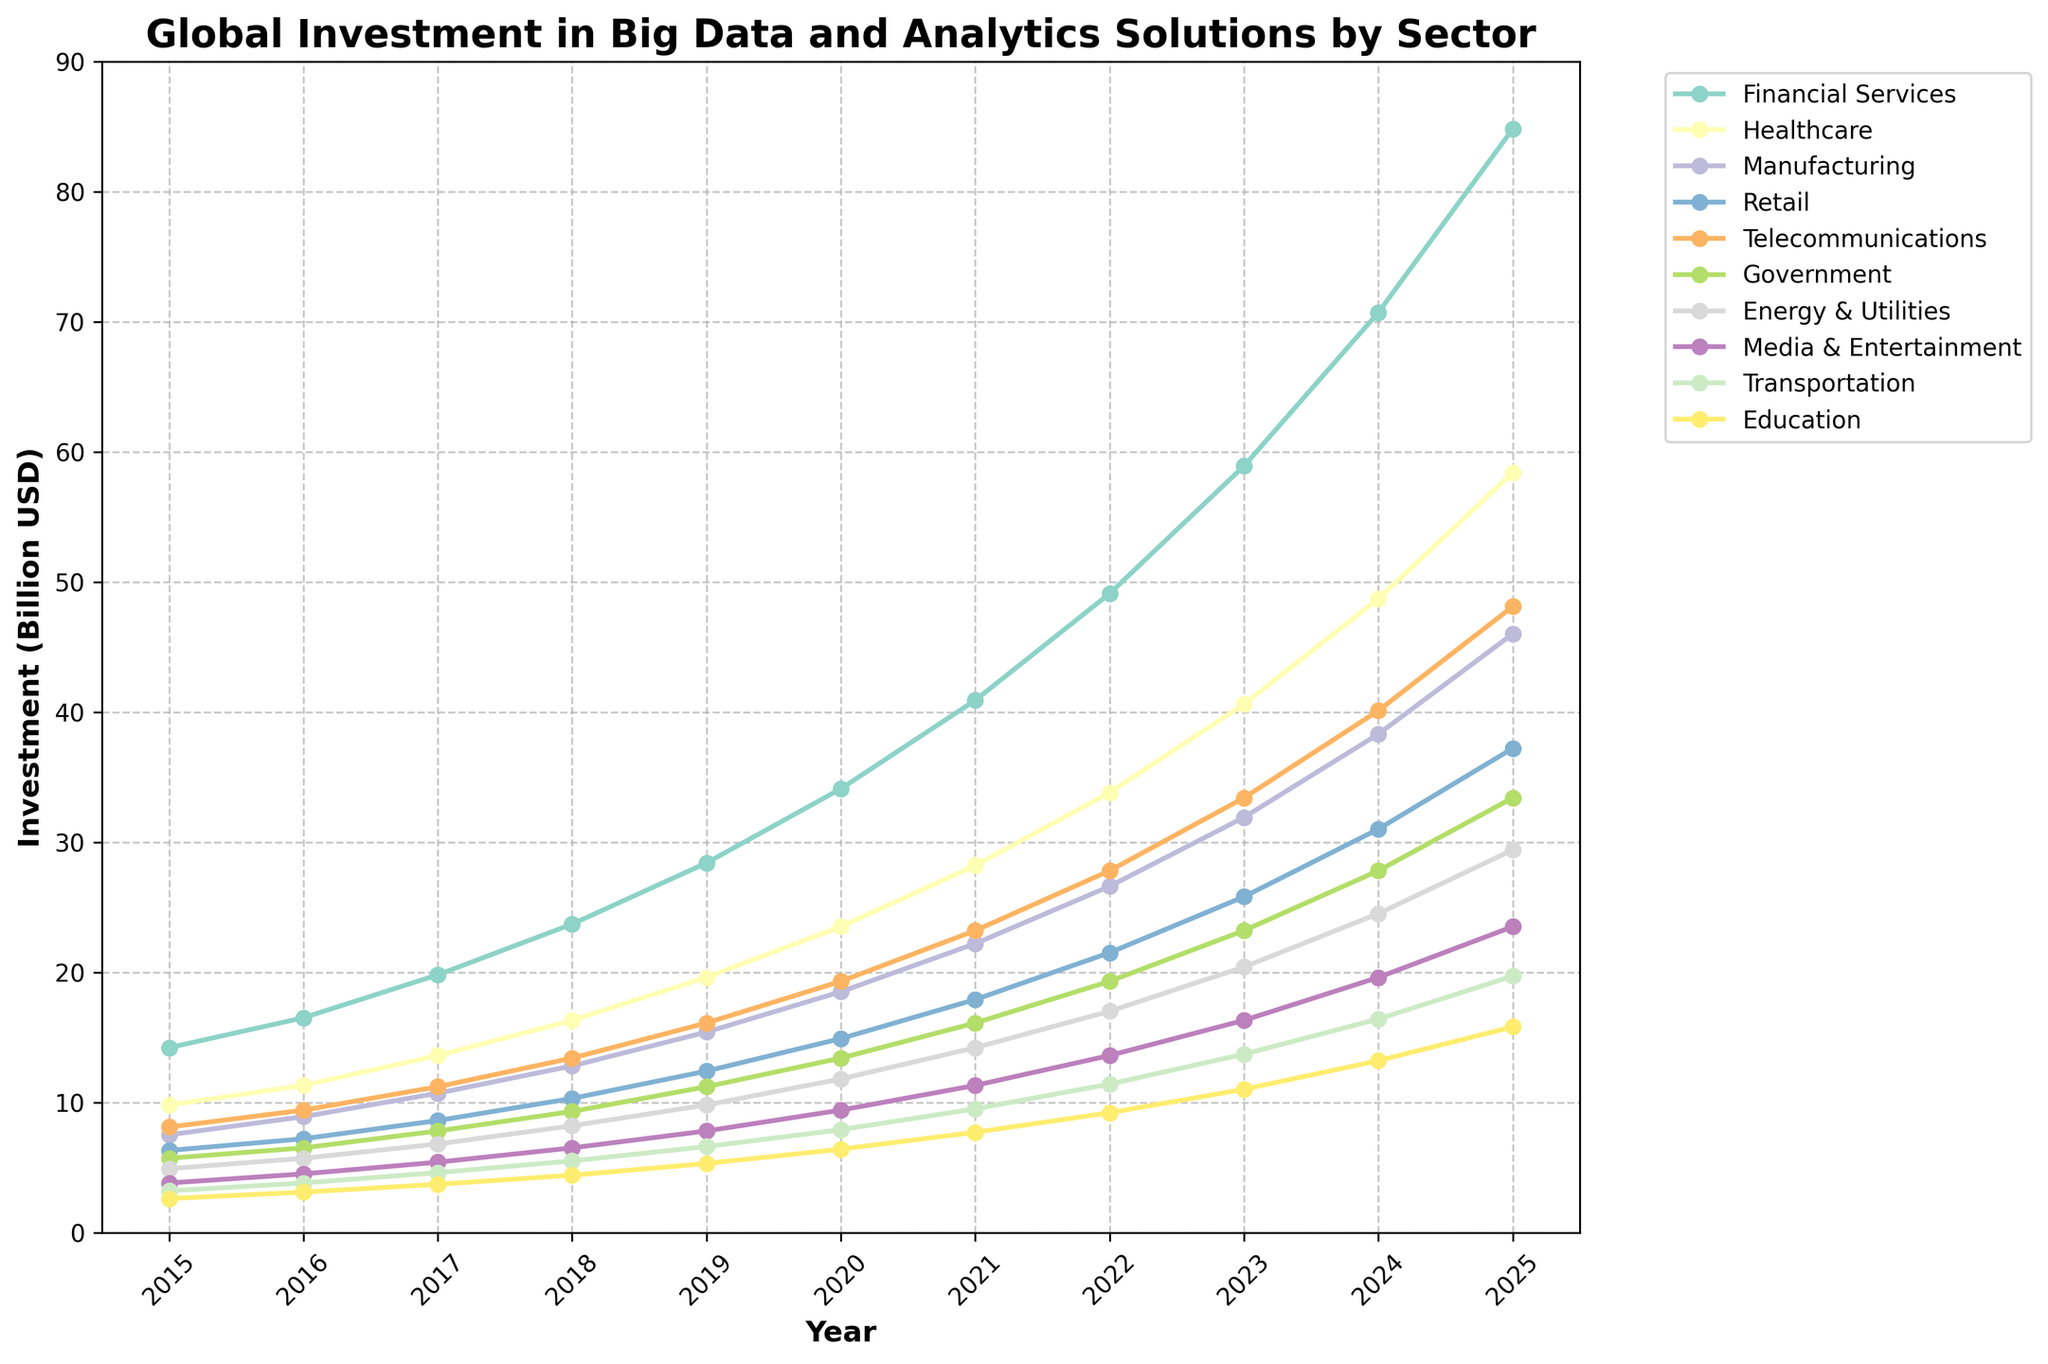How did the investments in the healthcare sector change from 2015 to 2025? To determine this, we look at the line representing the healthcare sector. In 2015, the investment was 9.8 billion USD, and in 2025, it rose to 58.4 billion USD. Therefore, there was an increase of 48.6 billion USD over these years.
Answer: Increased by 48.6 billion USD Which sector had the highest investment in 2025? By examining the endpoint of the lines for each sector in 2025, it is clear that the financial services sector had the highest investment, reaching 84.8 billion USD.
Answer: Financial Services What is the difference in investment between the manufacturing and retail sectors in 2024? We locate the points for the manufacturing (38.3 billion USD) and retail (31.0 billion USD) sectors in 2024 and subtract the value of retail from manufacturing: 38.3 - 31.0 = 7.3 billion USD.
Answer: 7.3 billion USD Which two sectors had the most significant increase in investment from 2015 to 2020? By comparing the rise for each sector between these two years, the financial services sector increased from 14.2 to 34.1 billion USD (increase of 19.9 billion USD) and the healthcare sector from 9.8 to 23.5 billion USD (increase of 13.7 billion USD). These are the two largest increases.
Answer: Financial Services and Healthcare In which year did the telecommunications sector surpass 25 billion USD in investment? Examining the telecommunications line, it is observed that it reaches 25.8 billion USD in 2023, surpassing the 25 billion USD threshold.
Answer: 2023 What was the total investment in big data and analytics solutions for all sectors combined in 2017? Adding up the investments for all sectors in 2017: 19.8 + 13.6 + 10.7 + 8.6 + 11.2 + 7.8 + 6.8 + 5.4 + 4.6 + 3.7 = 92.2 billion USD.
Answer: 92.2 billion USD Which sector consistently showed an increase in investment every year from 2015 to 2025? By inspecting the trend lines for all sectors, we see that all sectors show a consistent yearly increase. Any individual sector could be chosen to answer this question.
Answer: Any sector (e.g., Financial Services) How much more was invested in the energy & utilities sector than in education in 2025? In 2025, the investment in the energy & utilities sector was 29.4 billion USD, and for education, it was 15.8 billion USD. The difference is 29.4 - 15.8 = 13.6 billion USD.
Answer: 13.6 billion USD Which sector had the steepest growth between 2023 and 2025? Looking for the sector with the sharpest increase between these years, financial services grew from 58.9 to 84.8 billion USD (growth of 25.9 billion USD), which is the highest increase among all sectors for this period.
Answer: Financial Services 